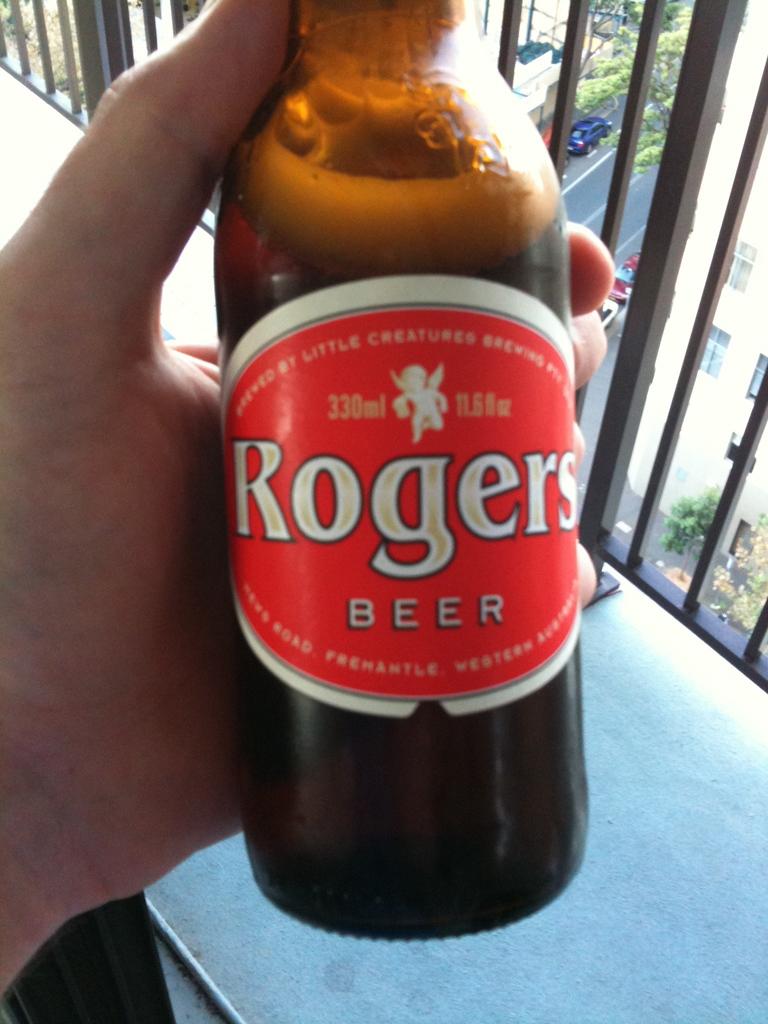How brews this beer?
Provide a succinct answer. Rogers. 